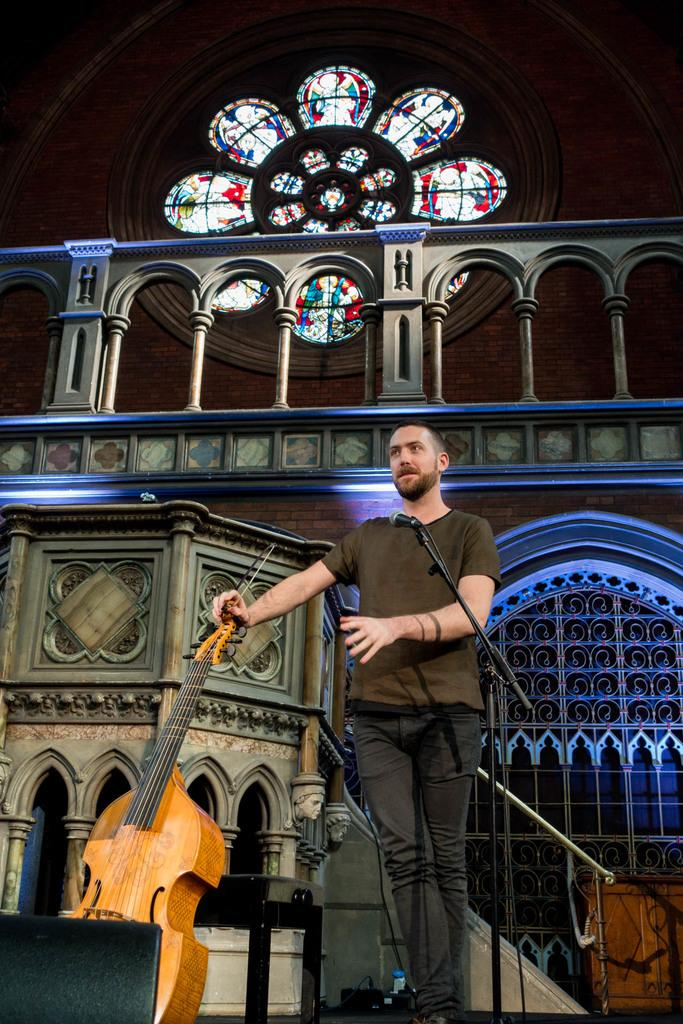What is the main subject of the image? There is a man in the image. What is the man doing in the image? The man is standing in the image. What object is the man holding in the image? The man is holding a violin in the image. What device is present for amplifying sound in the image? There is a microphone in the image. What can be seen in the background of the image? There is a building in the background of the image. What type of bubble can be seen floating near the man in the image? There is no bubble present in the image. Can you describe the yak that is standing next to the man in the image? There is no yak present in the image; the man is holding a violin and standing near a microphone. 